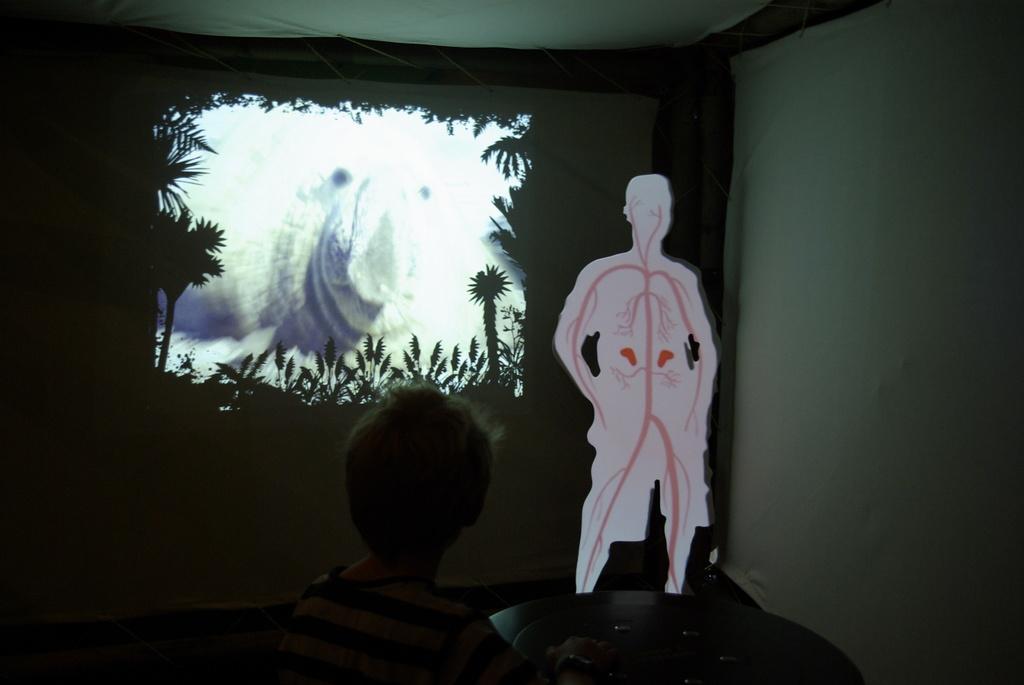In one or two sentences, can you explain what this image depicts? In this image there is a person at the bottom of the image. Right side there is a person structure. Behind there is a screen having few trees and an animal displayed on it. Background there is a wall. 